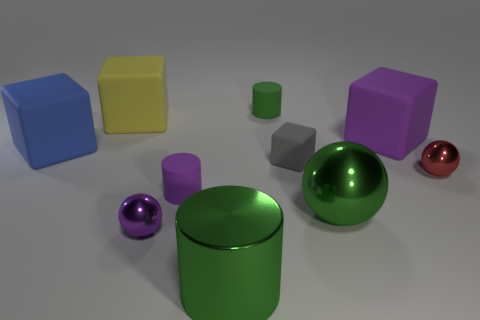Subtract all brown cubes. How many green cylinders are left? 2 Subtract all gray blocks. How many blocks are left? 3 Subtract all red cubes. Subtract all yellow balls. How many cubes are left? 4 Subtract all blocks. How many objects are left? 6 Add 7 small metallic spheres. How many small metallic spheres are left? 9 Add 2 brown metal blocks. How many brown metal blocks exist? 2 Subtract 0 cyan balls. How many objects are left? 10 Subtract all large matte cubes. Subtract all big rubber things. How many objects are left? 4 